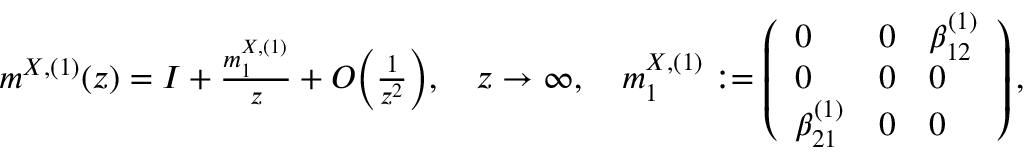<formula> <loc_0><loc_0><loc_500><loc_500>\begin{array} { r } { m ^ { X , ( 1 ) } ( z ) = I + \frac { m _ { 1 } ^ { X , ( 1 ) } } { z } + O \left ( \frac { 1 } { z ^ { 2 } } \right ) , \quad z \to \infty , \quad m _ { 1 } ^ { X , ( 1 ) } \colon = \left ( \begin{array} { l l l } { 0 } & { 0 } & { \beta _ { 1 2 } ^ { ( 1 ) } } \\ { 0 } & { 0 } & { 0 } \\ { \beta _ { 2 1 } ^ { ( 1 ) } } & { 0 } & { 0 } \end{array} \right ) , } \end{array}</formula> 